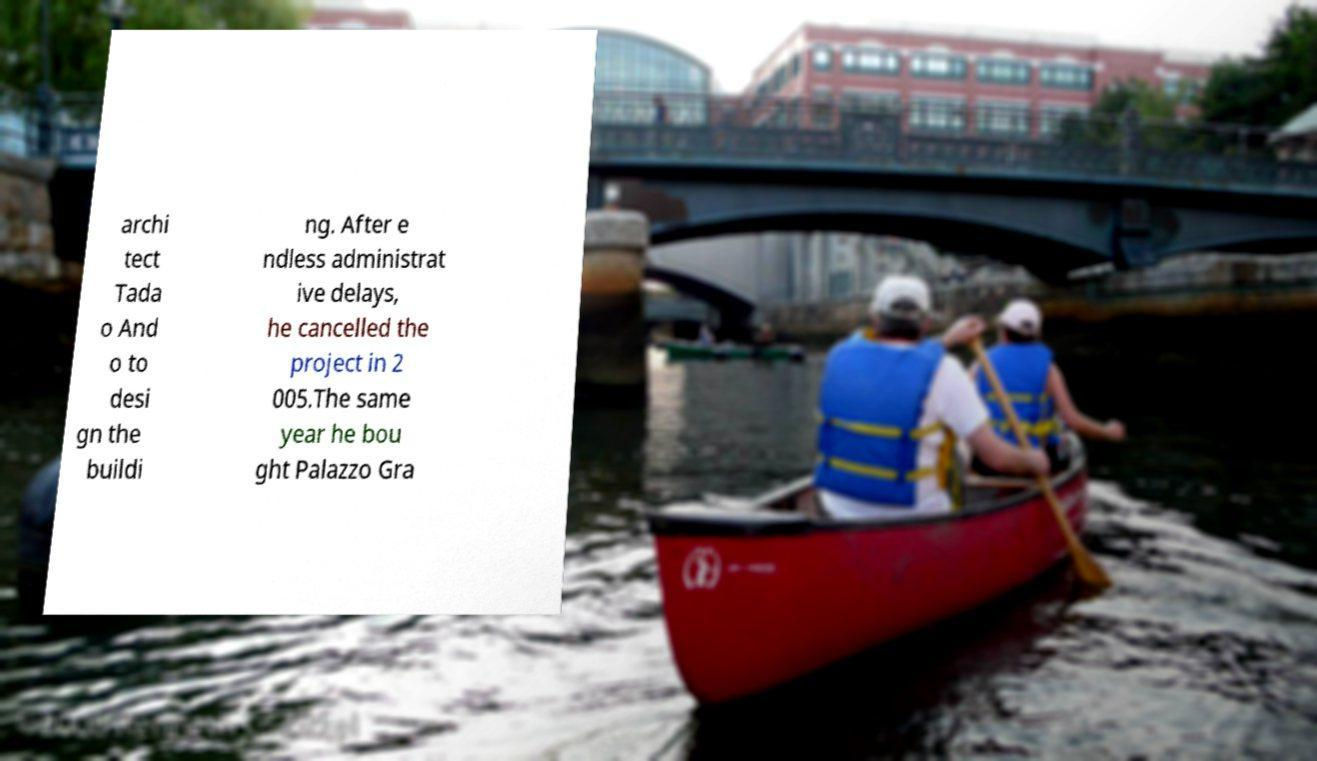Could you extract and type out the text from this image? archi tect Tada o And o to desi gn the buildi ng. After e ndless administrat ive delays, he cancelled the project in 2 005.The same year he bou ght Palazzo Gra 